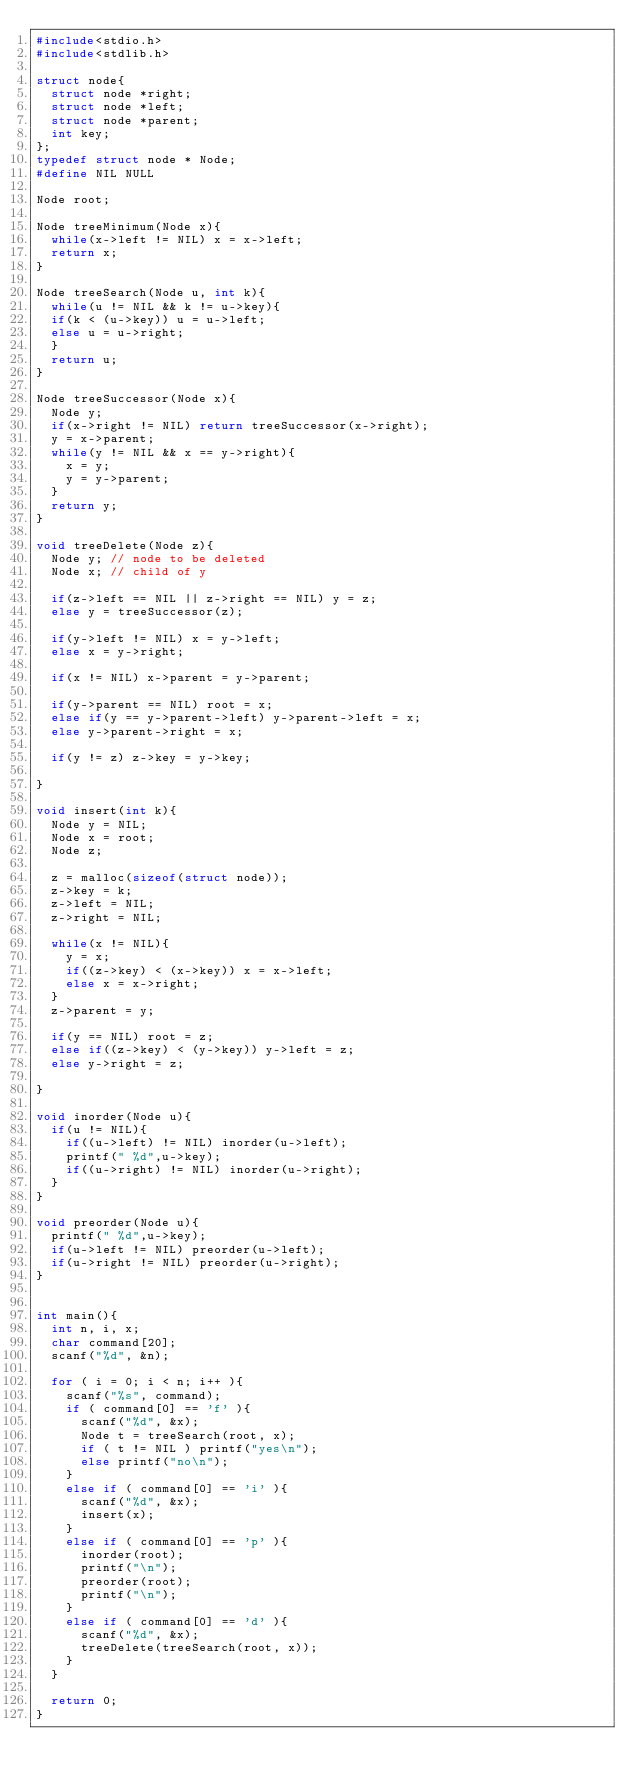<code> <loc_0><loc_0><loc_500><loc_500><_C_>#include<stdio.h>
#include<stdlib.h>

struct node{
  struct node *right;
  struct node *left;
  struct node *parent;
  int key;
};
typedef struct node * Node;
#define NIL NULL

Node root;

Node treeMinimum(Node x){
  while(x->left != NIL) x = x->left;
  return x;
}

Node treeSearch(Node u, int k){
  while(u != NIL && k != u->key){
  if(k < (u->key)) u = u->left;
  else u = u->right;
  }
  return u;
}

Node treeSuccessor(Node x){
  Node y;
  if(x->right != NIL) return treeSuccessor(x->right);
  y = x->parent;
  while(y != NIL && x == y->right){
    x = y;
    y = y->parent;
  }
  return y;
}

void treeDelete(Node z){
  Node y; // node to be deleted
  Node x; // child of y

  if(z->left == NIL || z->right == NIL) y = z;
  else y = treeSuccessor(z);

  if(y->left != NIL) x = y->left;
  else x = y->right;

  if(x != NIL) x->parent = y->parent;

  if(y->parent == NIL) root = x;
  else if(y == y->parent->left) y->parent->left = x;
  else y->parent->right = x;

  if(y != z) z->key = y->key;

}

void insert(int k){
  Node y = NIL;
  Node x = root;
  Node z;

  z = malloc(sizeof(struct node));
  z->key = k;
  z->left = NIL;
  z->right = NIL;

  while(x != NIL){
    y = x;
    if((z->key) < (x->key)) x = x->left;
    else x = x->right;
  }
  z->parent = y;

  if(y == NIL) root = z;
  else if((z->key) < (y->key)) y->left = z;
  else y->right = z;

}

void inorder(Node u){
  if(u != NIL){
    if((u->left) != NIL) inorder(u->left);
    printf(" %d",u->key);
    if((u->right) != NIL) inorder(u->right);
  }
}

void preorder(Node u){
  printf(" %d",u->key);
  if(u->left != NIL) preorder(u->left);
  if(u->right != NIL) preorder(u->right);
}


int main(){
  int n, i, x;
  char command[20];
  scanf("%d", &n);

  for ( i = 0; i < n; i++ ){
    scanf("%s", command);
    if ( command[0] == 'f' ){
      scanf("%d", &x);
      Node t = treeSearch(root, x);
      if ( t != NIL ) printf("yes\n");
      else printf("no\n");
    }
    else if ( command[0] == 'i' ){
      scanf("%d", &x);
      insert(x);
    }
    else if ( command[0] == 'p' ){
      inorder(root);
      printf("\n");
      preorder(root);
      printf("\n");
    }
    else if ( command[0] == 'd' ){
      scanf("%d", &x);
      treeDelete(treeSearch(root, x));
    }
  }

  return 0;
}</code> 